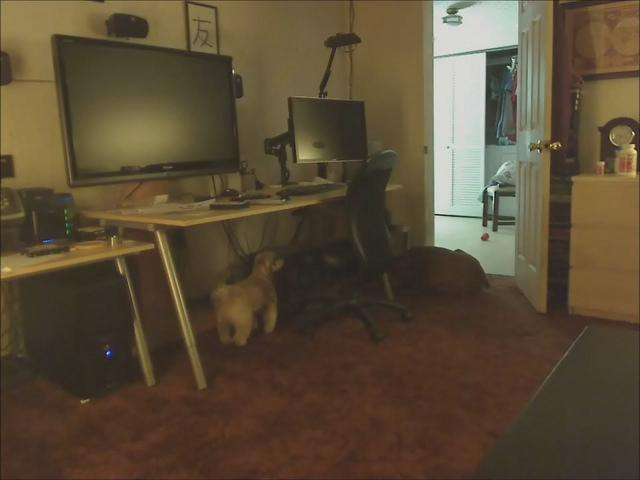The thing that is under the desk belongs to what family? Please explain your reasoning. canidae. The animal under the desk is a dog and belongs to the canine family. 